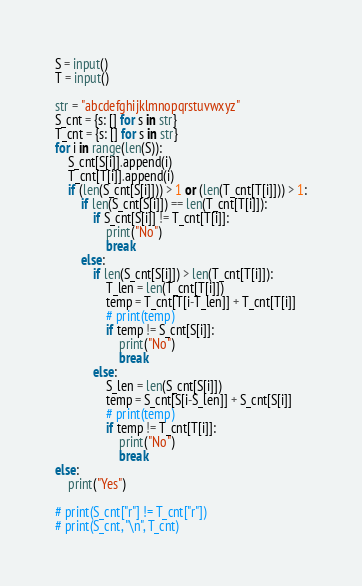Convert code to text. <code><loc_0><loc_0><loc_500><loc_500><_Python_>S = input()
T = input()

str = "abcdefghijklmnopqrstuvwxyz"
S_cnt = {s: [] for s in str}
T_cnt = {s: [] for s in str}
for i in range(len(S)):
    S_cnt[S[i]].append(i)
    T_cnt[T[i]].append(i)
    if (len(S_cnt[S[i]])) > 1 or (len(T_cnt[T[i]])) > 1:
        if len(S_cnt[S[i]]) == len(T_cnt[T[i]]):
            if S_cnt[S[i]] != T_cnt[T[i]]:
                print("No")
                break
        else:
            if len(S_cnt[S[i]]) > len(T_cnt[T[i]]):
                T_len = len(T_cnt[T[i]])
                temp = T_cnt[T[i-T_len]] + T_cnt[T[i]]
                # print(temp)
                if temp != S_cnt[S[i]]:
                    print("No")
                    break
            else:
                S_len = len(S_cnt[S[i]])
                temp = S_cnt[S[i-S_len]] + S_cnt[S[i]]
                # print(temp)
                if temp != T_cnt[T[i]]:
                    print("No")
                    break
else:
    print("Yes")

# print(S_cnt["r"] != T_cnt["r"])
# print(S_cnt, "\n", T_cnt)
</code> 